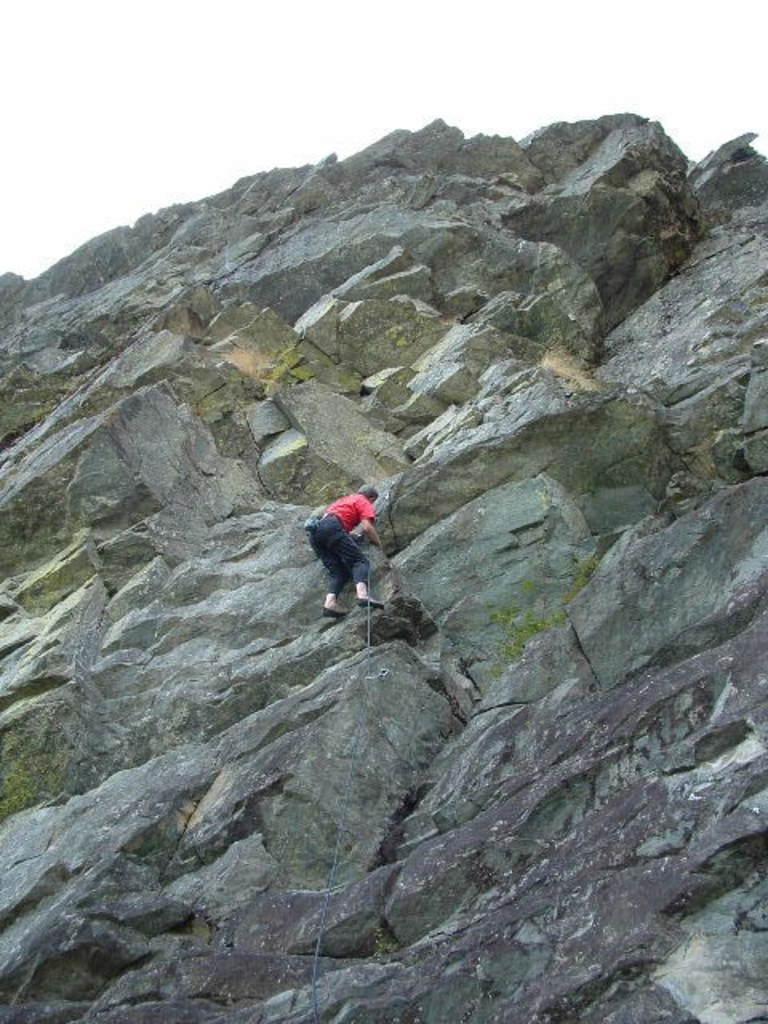Describe this image in one or two sentences. In this image I can see the person climbing the rock and the person is wearing red and black color dress. Background the sky is in white color. 